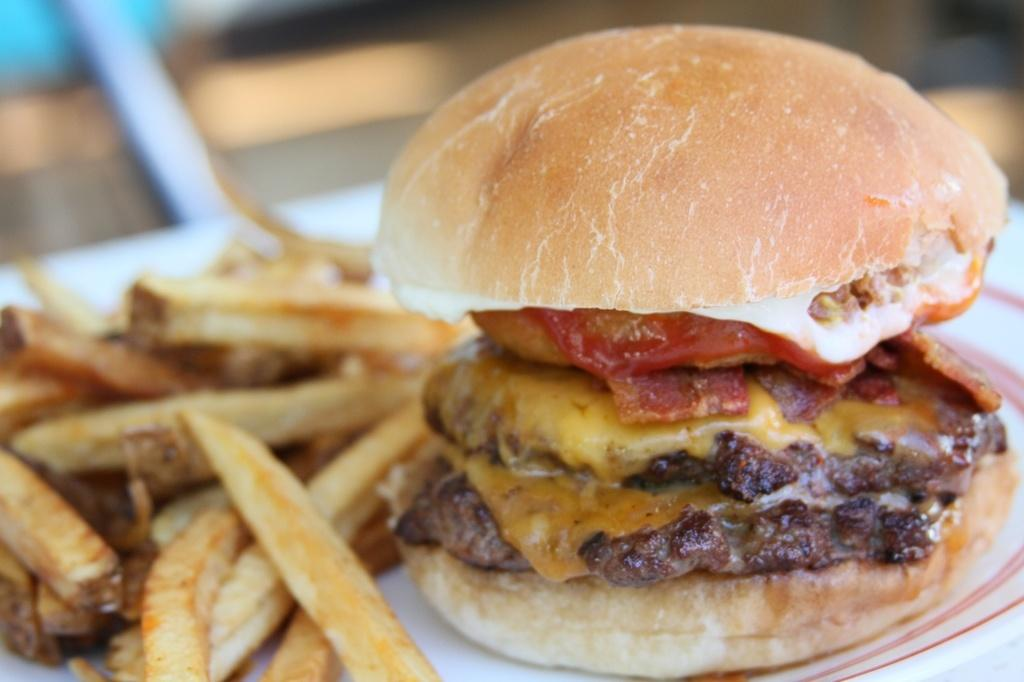What type of food is on the plate in the image? There is a burger on the plate in the image. What else is on the plate with the burger? There are fries on the plate in the image. Can you describe the background of the image? The background of the image is blurry. What key is used to unlock the burger in the image? There is no key present in the image, and burgers do not require keys to be unlocked. 